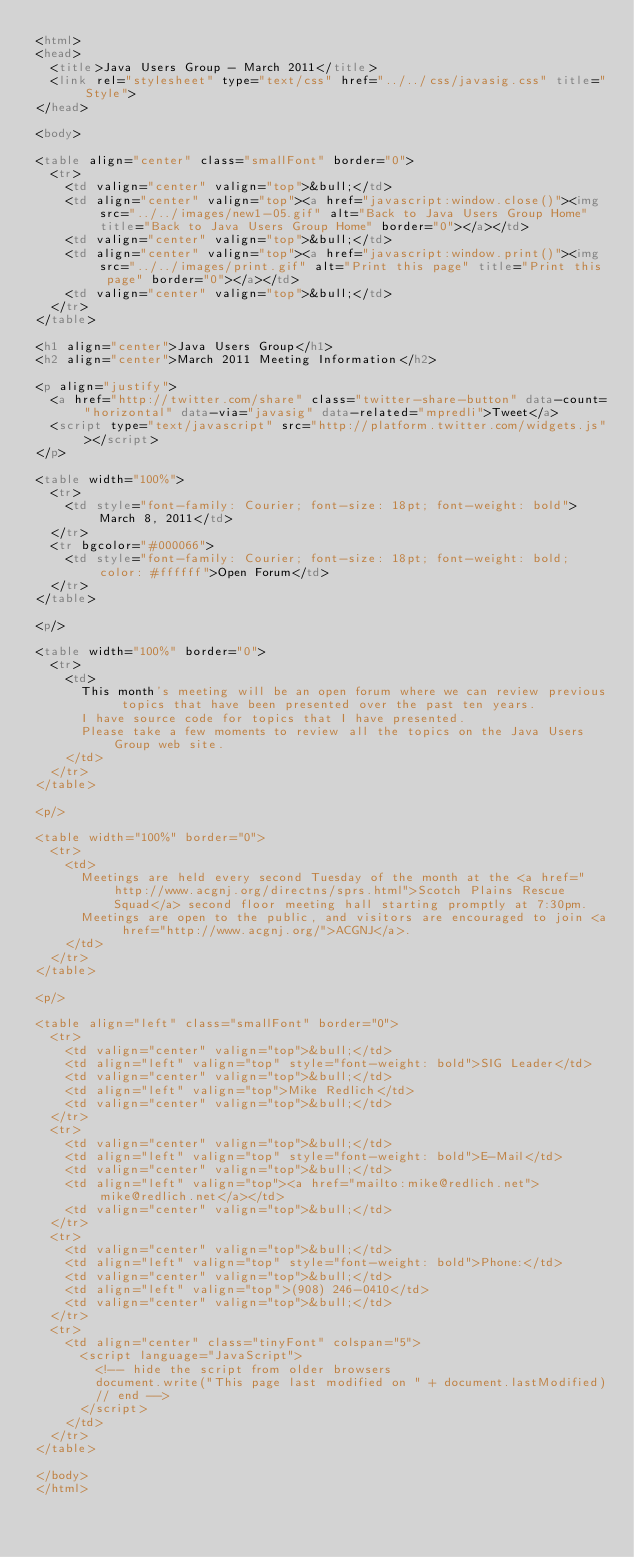<code> <loc_0><loc_0><loc_500><loc_500><_HTML_><html>
<head>
	<title>Java Users Group - March 2011</title>
	<link rel="stylesheet" type="text/css" href="../../css/javasig.css" title="Style">
</head>

<body>

<table align="center" class="smallFont" border="0">
	<tr>
		<td valign="center" valign="top">&bull;</td>
		<td align="center" valign="top"><a href="javascript:window.close()"><img src="../../images/new1-05.gif" alt="Back to Java Users Group Home" title="Back to Java Users Group Home" border="0"></a></td>
		<td valign="center" valign="top">&bull;</td>
		<td align="center" valign="top"><a href="javascript:window.print()"><img src="../../images/print.gif" alt="Print this page" title="Print this page" border="0"></a></td>
		<td valign="center" valign="top">&bull;</td>
	</tr>
</table>

<h1 align="center">Java Users Group</h1>
<h2 align="center">March 2011 Meeting Information</h2>

<p align="justify">
	<a href="http://twitter.com/share" class="twitter-share-button" data-count="horizontal" data-via="javasig" data-related="mpredli">Tweet</a>
	<script type="text/javascript" src="http://platform.twitter.com/widgets.js"></script>
</p>

<table width="100%">
	<tr>
		<td style="font-family: Courier; font-size: 18pt; font-weight: bold">March 8, 2011</td>
	</tr>
	<tr bgcolor="#000066">
		<td style="font-family: Courier; font-size: 18pt; font-weight: bold; color: #ffffff">Open Forum</td>
	</tr>
</table>

<p/>

<table width="100%" border="0">
	<tr>
		<td>
			This month's meeting will be an open forum where we can review previous topics that have been presented over the past ten years.
			I have source code for topics that I have presented.
			Please take a few moments to review all the topics on the Java Users Group web site.
		</td>
	</tr>
</table>

<p/>

<table width="100%" border="0">
	<tr>
		<td>
			Meetings are held every second Tuesday of the month at the <a href="http://www.acgnj.org/directns/sprs.html">Scotch Plains Rescue Squad</a> second floor meeting hall starting promptly at 7:30pm.
			Meetings are open to the public, and visitors are encouraged to join <a href="http://www.acgnj.org/">ACGNJ</a>.
		</td>
	</tr>
</table>

<p/>

<table align="left" class="smallFont" border="0">
	<tr>
		<td valign="center" valign="top">&bull;</td>
		<td align="left" valign="top" style="font-weight: bold">SIG Leader</td>
		<td valign="center" valign="top">&bull;</td>
		<td align="left" valign="top">Mike Redlich</td>
		<td valign="center" valign="top">&bull;</td>
	</tr>
	<tr>
		<td valign="center" valign="top">&bull;</td>
		<td align="left" valign="top" style="font-weight: bold">E-Mail</td>
		<td valign="center" valign="top">&bull;</td>
		<td align="left" valign="top"><a href="mailto:mike@redlich.net">mike@redlich.net</a></td>
		<td valign="center" valign="top">&bull;</td>
	</tr>
	<tr>
		<td valign="center" valign="top">&bull;</td>
		<td align="left" valign="top" style="font-weight: bold">Phone:</td>
		<td valign="center" valign="top">&bull;</td>
		<td align="left" valign="top">(908) 246-0410</td>
		<td valign="center" valign="top">&bull;</td>
	</tr>
	<tr>
		<td align="center" class="tinyFont" colspan="5">
			<script language="JavaScript">
				<!-- hide the script from older browsers
				document.write("This page last modified on " + document.lastModified)
				// end -->
			</script>
		</td>
	</tr>
</table>

</body>
</html>
</code> 